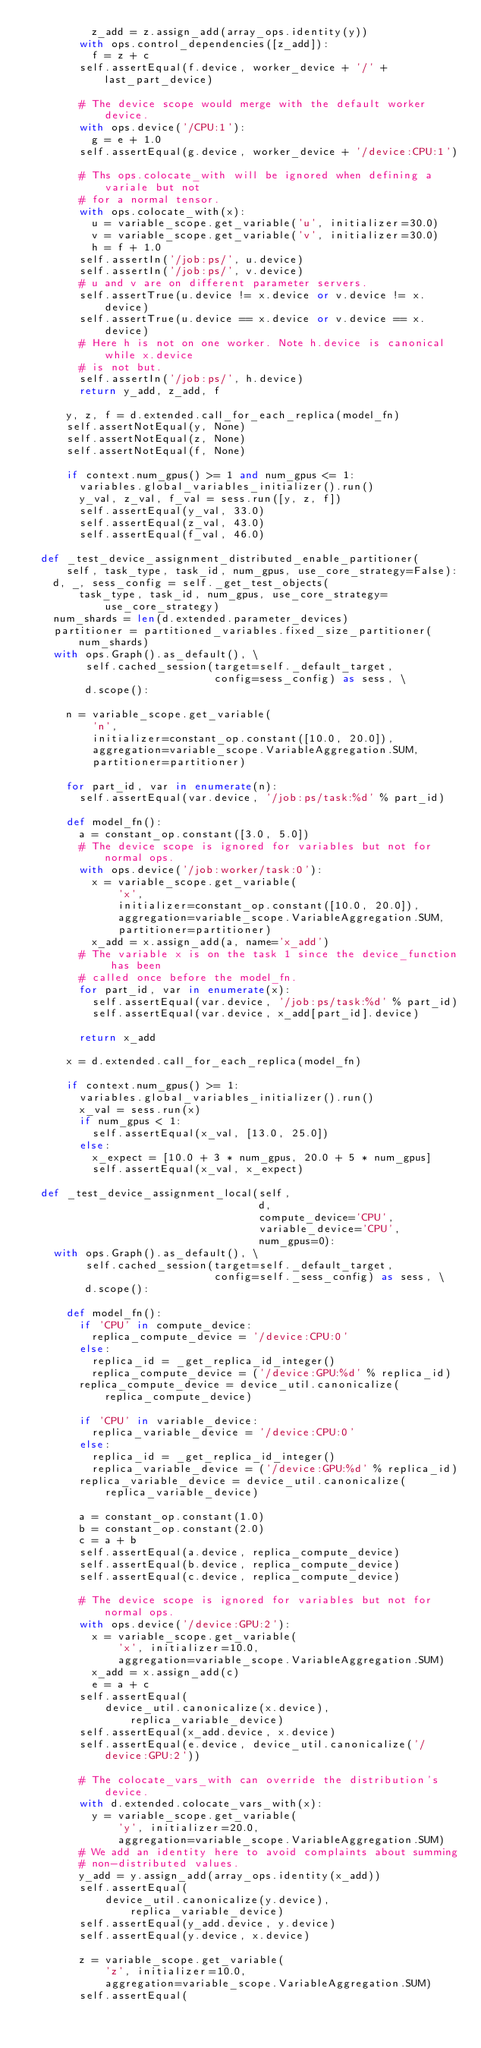<code> <loc_0><loc_0><loc_500><loc_500><_Python_>          z_add = z.assign_add(array_ops.identity(y))
        with ops.control_dependencies([z_add]):
          f = z + c
        self.assertEqual(f.device, worker_device + '/' + last_part_device)

        # The device scope would merge with the default worker device.
        with ops.device('/CPU:1'):
          g = e + 1.0
        self.assertEqual(g.device, worker_device + '/device:CPU:1')

        # Ths ops.colocate_with will be ignored when defining a variale but not
        # for a normal tensor.
        with ops.colocate_with(x):
          u = variable_scope.get_variable('u', initializer=30.0)
          v = variable_scope.get_variable('v', initializer=30.0)
          h = f + 1.0
        self.assertIn('/job:ps/', u.device)
        self.assertIn('/job:ps/', v.device)
        # u and v are on different parameter servers.
        self.assertTrue(u.device != x.device or v.device != x.device)
        self.assertTrue(u.device == x.device or v.device == x.device)
        # Here h is not on one worker. Note h.device is canonical while x.device
        # is not but.
        self.assertIn('/job:ps/', h.device)
        return y_add, z_add, f

      y, z, f = d.extended.call_for_each_replica(model_fn)
      self.assertNotEqual(y, None)
      self.assertNotEqual(z, None)
      self.assertNotEqual(f, None)

      if context.num_gpus() >= 1 and num_gpus <= 1:
        variables.global_variables_initializer().run()
        y_val, z_val, f_val = sess.run([y, z, f])
        self.assertEqual(y_val, 33.0)
        self.assertEqual(z_val, 43.0)
        self.assertEqual(f_val, 46.0)

  def _test_device_assignment_distributed_enable_partitioner(
      self, task_type, task_id, num_gpus, use_core_strategy=False):
    d, _, sess_config = self._get_test_objects(
        task_type, task_id, num_gpus, use_core_strategy=use_core_strategy)
    num_shards = len(d.extended.parameter_devices)
    partitioner = partitioned_variables.fixed_size_partitioner(num_shards)
    with ops.Graph().as_default(), \
         self.cached_session(target=self._default_target,
                             config=sess_config) as sess, \
         d.scope():

      n = variable_scope.get_variable(
          'n',
          initializer=constant_op.constant([10.0, 20.0]),
          aggregation=variable_scope.VariableAggregation.SUM,
          partitioner=partitioner)

      for part_id, var in enumerate(n):
        self.assertEqual(var.device, '/job:ps/task:%d' % part_id)

      def model_fn():
        a = constant_op.constant([3.0, 5.0])
        # The device scope is ignored for variables but not for normal ops.
        with ops.device('/job:worker/task:0'):
          x = variable_scope.get_variable(
              'x',
              initializer=constant_op.constant([10.0, 20.0]),
              aggregation=variable_scope.VariableAggregation.SUM,
              partitioner=partitioner)
          x_add = x.assign_add(a, name='x_add')
        # The variable x is on the task 1 since the device_function has been
        # called once before the model_fn.
        for part_id, var in enumerate(x):
          self.assertEqual(var.device, '/job:ps/task:%d' % part_id)
          self.assertEqual(var.device, x_add[part_id].device)

        return x_add

      x = d.extended.call_for_each_replica(model_fn)

      if context.num_gpus() >= 1:
        variables.global_variables_initializer().run()
        x_val = sess.run(x)
        if num_gpus < 1:
          self.assertEqual(x_val, [13.0, 25.0])
        else:
          x_expect = [10.0 + 3 * num_gpus, 20.0 + 5 * num_gpus]
          self.assertEqual(x_val, x_expect)

  def _test_device_assignment_local(self,
                                    d,
                                    compute_device='CPU',
                                    variable_device='CPU',
                                    num_gpus=0):
    with ops.Graph().as_default(), \
         self.cached_session(target=self._default_target,
                             config=self._sess_config) as sess, \
         d.scope():

      def model_fn():
        if 'CPU' in compute_device:
          replica_compute_device = '/device:CPU:0'
        else:
          replica_id = _get_replica_id_integer()
          replica_compute_device = ('/device:GPU:%d' % replica_id)
        replica_compute_device = device_util.canonicalize(
            replica_compute_device)

        if 'CPU' in variable_device:
          replica_variable_device = '/device:CPU:0'
        else:
          replica_id = _get_replica_id_integer()
          replica_variable_device = ('/device:GPU:%d' % replica_id)
        replica_variable_device = device_util.canonicalize(
            replica_variable_device)

        a = constant_op.constant(1.0)
        b = constant_op.constant(2.0)
        c = a + b
        self.assertEqual(a.device, replica_compute_device)
        self.assertEqual(b.device, replica_compute_device)
        self.assertEqual(c.device, replica_compute_device)

        # The device scope is ignored for variables but not for normal ops.
        with ops.device('/device:GPU:2'):
          x = variable_scope.get_variable(
              'x', initializer=10.0,
              aggregation=variable_scope.VariableAggregation.SUM)
          x_add = x.assign_add(c)
          e = a + c
        self.assertEqual(
            device_util.canonicalize(x.device), replica_variable_device)
        self.assertEqual(x_add.device, x.device)
        self.assertEqual(e.device, device_util.canonicalize('/device:GPU:2'))

        # The colocate_vars_with can override the distribution's device.
        with d.extended.colocate_vars_with(x):
          y = variable_scope.get_variable(
              'y', initializer=20.0,
              aggregation=variable_scope.VariableAggregation.SUM)
        # We add an identity here to avoid complaints about summing
        # non-distributed values.
        y_add = y.assign_add(array_ops.identity(x_add))
        self.assertEqual(
            device_util.canonicalize(y.device), replica_variable_device)
        self.assertEqual(y_add.device, y.device)
        self.assertEqual(y.device, x.device)

        z = variable_scope.get_variable(
            'z', initializer=10.0,
            aggregation=variable_scope.VariableAggregation.SUM)
        self.assertEqual(</code> 